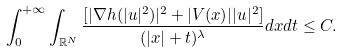Convert formula to latex. <formula><loc_0><loc_0><loc_500><loc_500>\int _ { 0 } ^ { + \infty } \int _ { \mathbb { R } ^ { N } } \frac { [ | \nabla h ( | u | ^ { 2 } ) | ^ { 2 } + | V ( x ) | | u | ^ { 2 } ] } { ( | x | + t ) ^ { \lambda } } d x d t \leq C .</formula> 